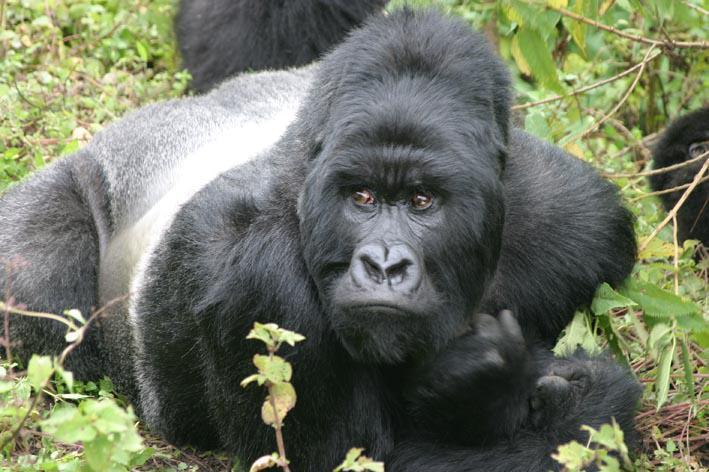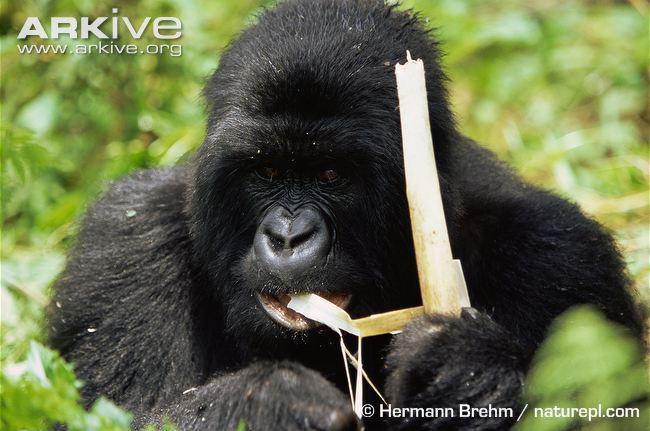The first image is the image on the left, the second image is the image on the right. Assess this claim about the two images: "One image shows exactly three gorillas, including a baby.". Correct or not? Answer yes or no. No. 